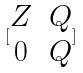Convert formula to latex. <formula><loc_0><loc_0><loc_500><loc_500>[ \begin{matrix} Z & Q \\ 0 & Q \end{matrix} ]</formula> 